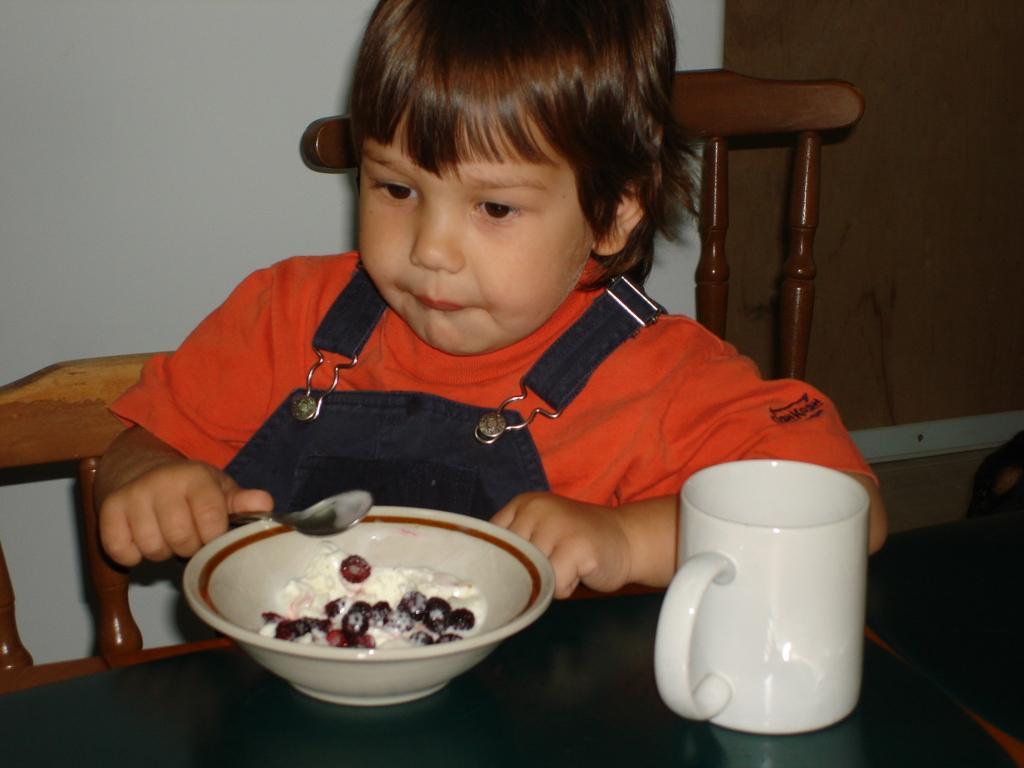In one or two sentences, can you explain what this image depicts? In this picture there is a boy wearing an orange t shirt is holding a spoon in his hand. There is a bowl and a cup on the table. This boy is sitting on the chair. 